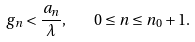<formula> <loc_0><loc_0><loc_500><loc_500>g _ { n } < \frac { a _ { n } } { \lambda } , \quad 0 \leq n \leq n _ { 0 } + 1 .</formula> 